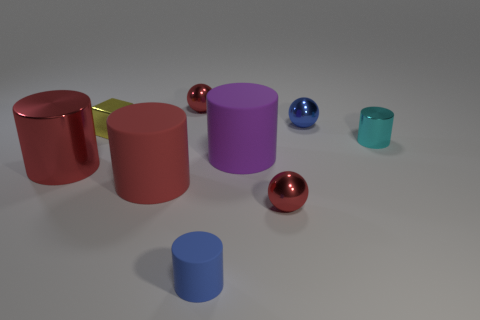How would you describe the arrangement of these objects? The objects are artfully arranged with careful consideration to balance and spacing, creating a visually pleasing still life tableau. This arrangement may suggest a deliberate study of form and color. 